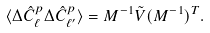<formula> <loc_0><loc_0><loc_500><loc_500>\langle \Delta \hat { C } ^ { p } _ { \ell } \Delta \hat { C } ^ { p } _ { \ell ^ { \prime } } \rangle = M ^ { - 1 } \tilde { V } ( M ^ { - 1 } ) ^ { T } .</formula> 